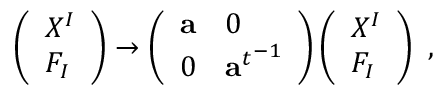Convert formula to latex. <formula><loc_0><loc_0><loc_500><loc_500>\left ( \begin{array} { l } { { X ^ { I } } } \\ { { F _ { I } } } \end{array} \right ) \rightarrow \left ( \begin{array} { l l } { a } & { 0 } \\ { 0 } & { { { { a } ^ { t } } ^ { - 1 } } } \end{array} \right ) \left ( \begin{array} { l } { { X ^ { I } } } \\ { { F _ { I } } } \end{array} \right ) \ ,</formula> 